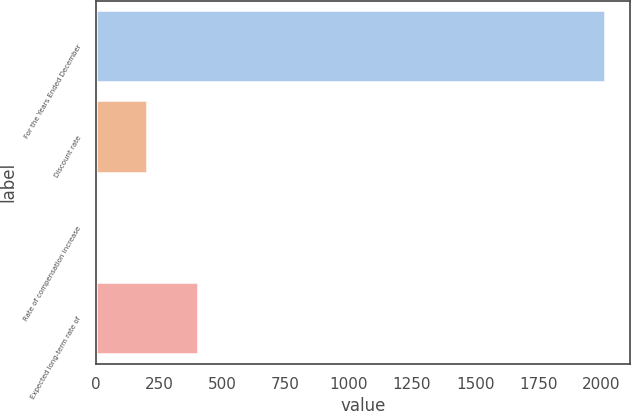Convert chart. <chart><loc_0><loc_0><loc_500><loc_500><bar_chart><fcel>For the Years Ended December<fcel>Discount rate<fcel>Rate of compensation increase<fcel>Expected long-term rate of<nl><fcel>2013<fcel>204.26<fcel>3.29<fcel>405.23<nl></chart> 